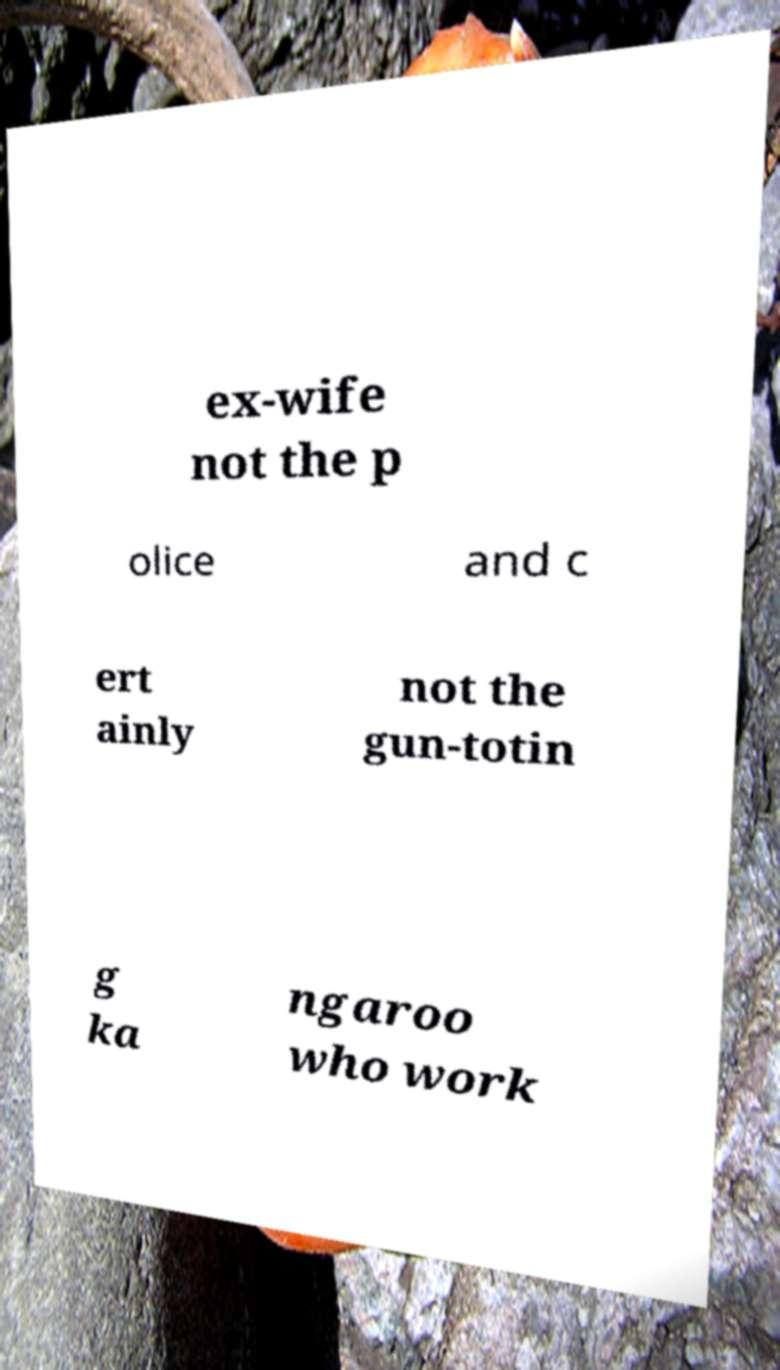For documentation purposes, I need the text within this image transcribed. Could you provide that? ex-wife not the p olice and c ert ainly not the gun-totin g ka ngaroo who work 